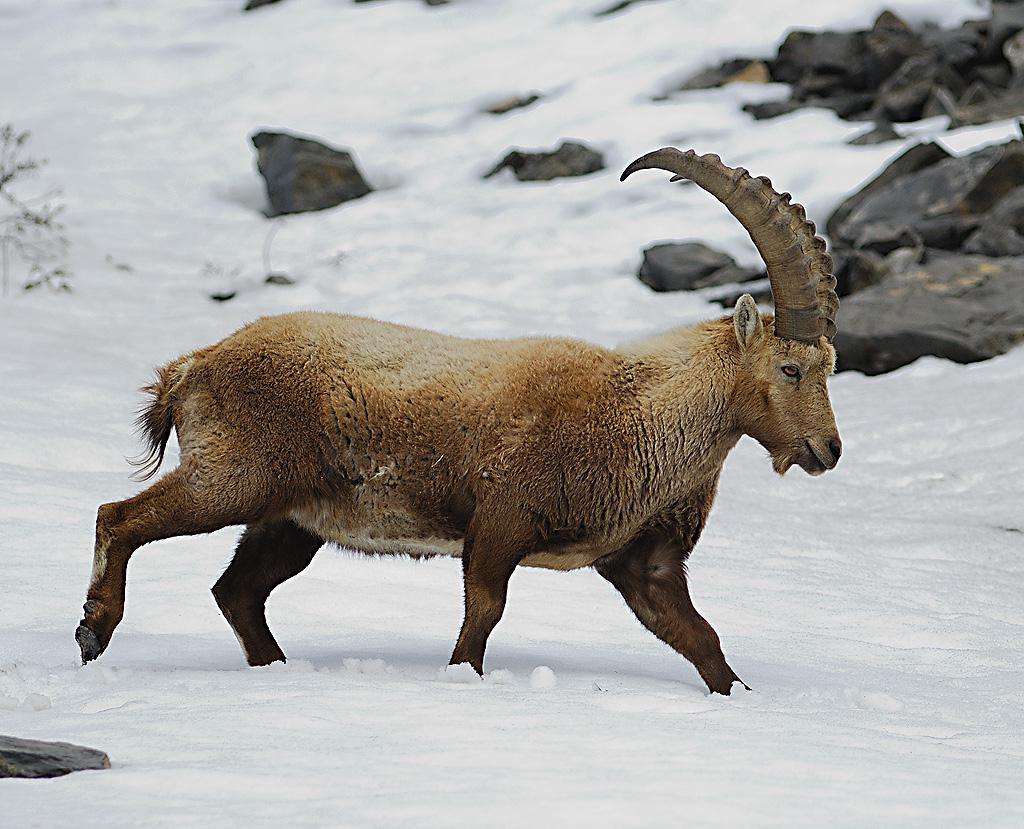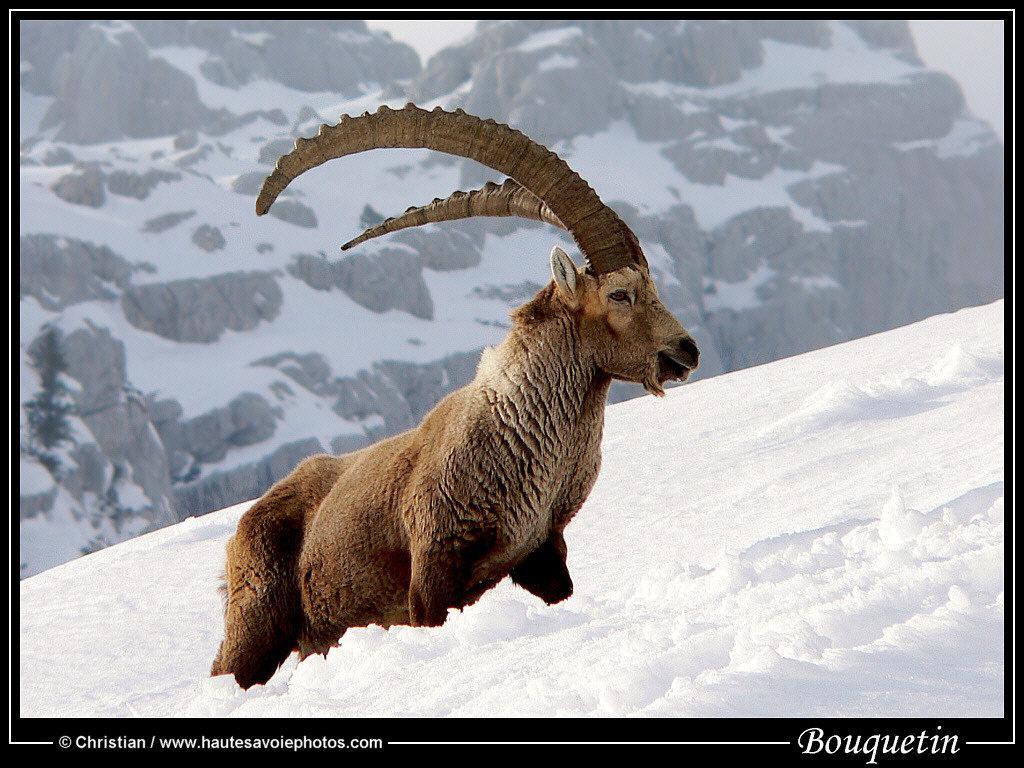The first image is the image on the left, the second image is the image on the right. Assess this claim about the two images: "At least one animal with large upright horns on its head is in a snowy area.". Correct or not? Answer yes or no. Yes. The first image is the image on the left, the second image is the image on the right. For the images displayed, is the sentence "There is at least 1 goat standing among plants." factually correct? Answer yes or no. No. 